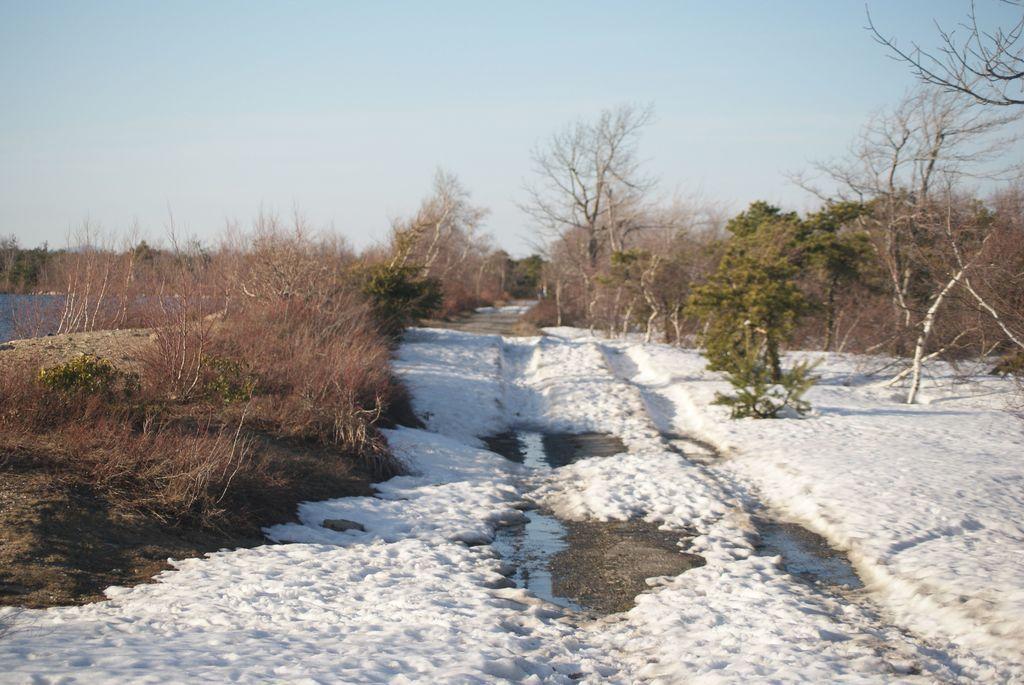How would you summarize this image in a sentence or two? In this image there is snow on the surface and there are trees everywhere. 